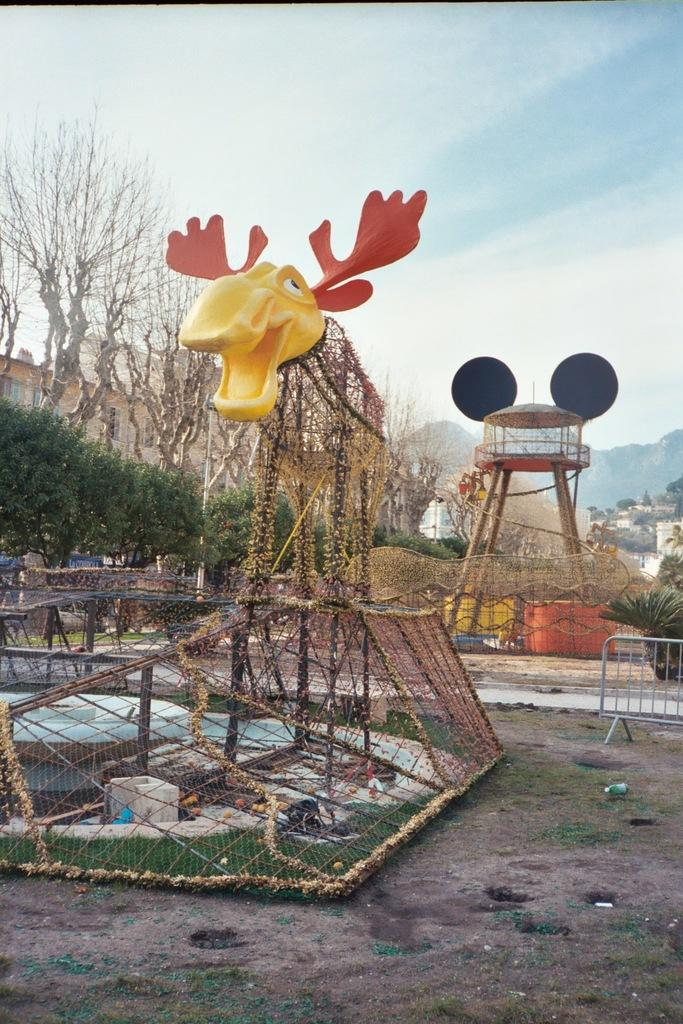What is the main subject in the middle of the image? There is a structure in the shape of an animal in the middle of the image. What can be seen on the left side of the image? There are trees on the left side of the image. What is visible at the top of the image? The sky is visible at the top of the image. Where is the dock located in the image? There is no dock present in the image. What type of tank can be seen in the image? There is no tank present in the image. 